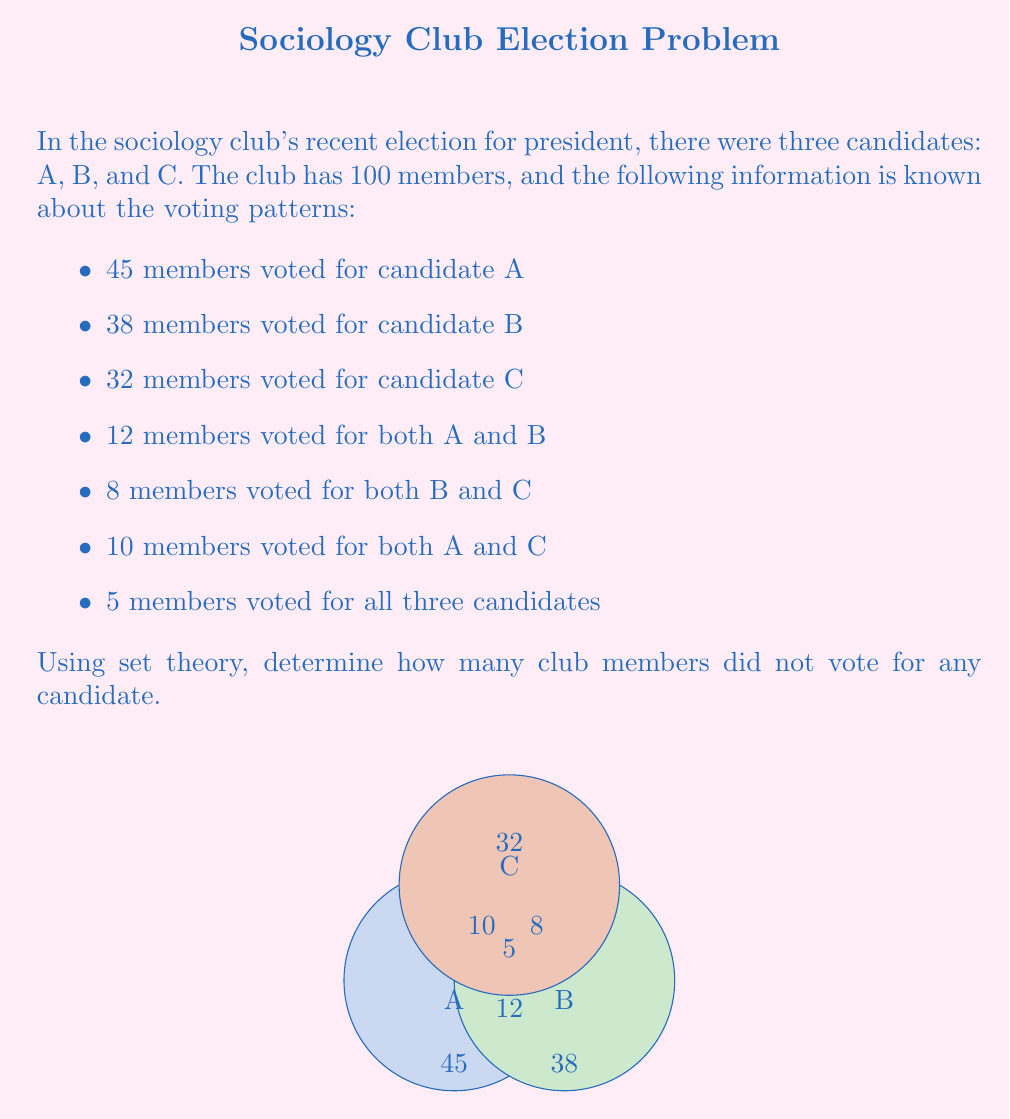Teach me how to tackle this problem. Let's approach this step-by-step using set theory:

1) Let's define our sets:
   A: members who voted for candidate A
   B: members who voted for candidate B
   C: members who voted for candidate C

2) We need to find the number of members in the union of these sets and subtract it from the total number of members:

   $|A \cup B \cup C| = |A| + |B| + |C| - |A \cap B| - |B \cap C| - |A \cap C| + |A \cap B \cap C|$

3) We know:
   $|A| = 45$, $|B| = 38$, $|C| = 32$
   $|A \cap B| = 12$, $|B \cap C| = 8$, $|A \cap C| = 10$
   $|A \cap B \cap C| = 5$

4) Let's substitute these values:

   $|A \cup B \cup C| = 45 + 38 + 32 - 12 - 8 - 10 + 5 = 90$

5) The number of members who voted for at least one candidate is 90.

6) Therefore, the number of members who didn't vote for any candidate is:

   Total members - Members who voted = 100 - 90 = 10
Answer: 10 members 